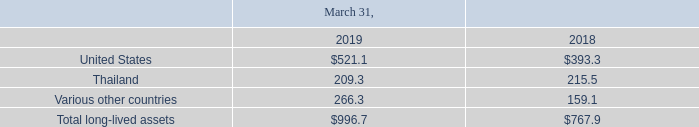The Company sells its products to distributors and original equipment manufacturers (OEMs) in a broad range of market segments, performs on-going credit evaluations of its customers and, as deemed necessary, may require collateral, primarily letters of credit. The Company's operations outside the U.S. consist of product assembly and final test facilities in Thailand, and sales and support centers and design centers in certain foreign countries. Domestic operations are responsible for the design, development and wafer fabrication of products, as well as the coordination of production planning and shipping to meet worldwide customer commitments. The Company's Thailand assembly and test facility is reimbursed in relation to value added with respect to assembly and test operations and other functions performed, and certain foreign sales offices receive compensation for sales within their territory. Accordingly, for financial statement purposes, it is not meaningful to segregate sales or operating profits for the assembly and test and foreign sales office operations. Identifiable long-lived assets (consisting of property, plant and equipment net of accumulated amortization) by geographic area are as follows (in millions):
Sales to unaffiliated customers located outside the U.S., primarily in Asia and Europe, aggregated approximately 80% of consolidated net sales for fiscal 2019 and approximately 85% and 84% of net sales during fiscal 2018 and fiscal 2017, respectively. Sales to customers in Europe represented approximately 23% of consolidated net sales for fiscal 2019 and approximately 24% of consolidated net sales for each of fiscal 2018 and fiscal 2017. Sales to customers in Asia represented approximately 52% of consolidated net sales for fiscal 2019 and approximately 58% of consolidated net sales for each of fiscal 2018 and 2017. Within Asia, sales into China represented approximately 22%, 30% and 32% of consolidated net sales for fiscal 2019, 2018 and 2017, respectively. Sales into Taiwan represented approximately 13%, 11% and 9% of consolidated net sales for fiscal 2019, 2018 and 2017, respectively. Sales into any other individual foreign country did not exceed 10% of the Company's net sales for any of the three years presented.
With the exception of Arrow Electronics, the Company's largest distributor, which made up 10% of net sales, no other distributor or end customer accounted for more than 10% of net sales in fiscal 2019. In fiscal 2018 and fiscal 2017, no distributor or end customer accounted for more than 10% of net sales.
Which years does the table provide information for Identifiable long-lived assets (consisting of property, plant and equipment net of accumulated amortization) by geographic area? 2019, 2018. What was the amount of assets in the United States in 2018?
Answer scale should be: million. 393.3. What was the amount of assets in Various other countries in 2019?
Answer scale should be: million. 266.3. What was the change in the amount of assets in Thailand between 2018 and 2019?
Answer scale should be: million. 209.3-215.5
Answer: -6.2. Which years did total long-lived assets exceed $800 million? (2019:996.7)
Answer: 2019. What was the percentage change in total long-lived assets between 2018 and 2019?
Answer scale should be: percent. (996.7-767.9)/767.9
Answer: 29.8. 